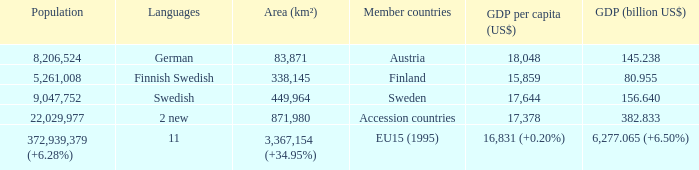Name the population for 11 languages 372,939,379 (+6.28%). 